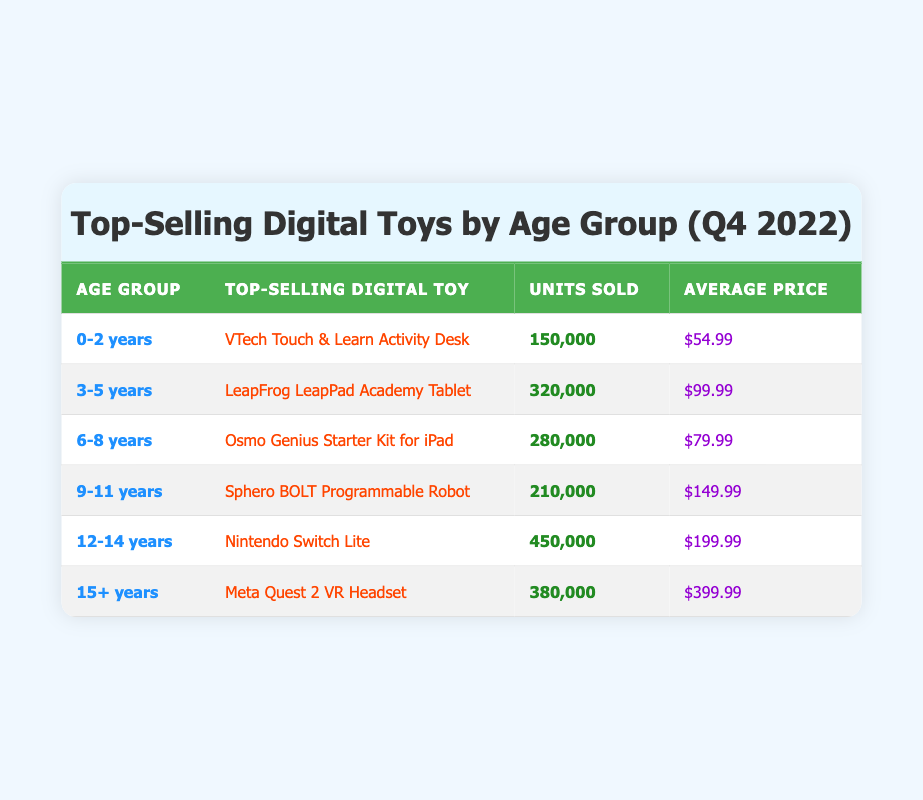What is the top-selling digital toy for the age group 3-5 years? By looking at the age group column for 3-5 years, the top-selling digital toy listed is the LeapFrog LeapPad Academy Tablet.
Answer: LeapFrog LeapPad Academy Tablet How many units of the Nintendo Switch Lite were sold? In the table, the units sold for the Nintendo Switch Lite in the age group of 12-14 years shows a total of 450,000 units.
Answer: 450,000 Which age group has the highest average price for digital toys? To determine this, we analyze the average prices of the toys: 54.99 (0-2 years), 99.99 (3-5 years), 79.99 (6-8 years), 149.99 (9-11 years), 199.99 (12-14 years), and 399.99 (15+ years). The age group 15+ years has the highest average price at 399.99.
Answer: 15+ years Is the VTech Touch & Learn Activity Desk the top-selling toy for any age group? Yes, the VTech Touch & Learn Activity Desk is listed as the top-selling digital toy for the age group of 0-2 years according to the table.
Answer: Yes What is the total number of units sold for toys in the age group 9-11 years and 12-14 years combined? The units sold for the age group 9-11 years is 210,000 and for 12-14 years is 450,000. Adding these together gives 210,000 + 450,000 = 660,000 units combined for these two age groups.
Answer: 660,000 Which toy sold the least units and what is that number? Referring to the units sold for toys, the VTech Touch & Learn Activity Desk sold 150,000 units, making it the toy with the least sales in the table.
Answer: 150,000 What is the difference in units sold between the top-selling toy for 12-14 years and the top-selling toy for 6-8 years? The top-selling toy for 12-14 years (Nintendo Switch Lite) sold 450,000 units, while the 6-8 years (Osmo Genius Starter Kit) sold 280,000 units. The difference is 450,000 - 280,000 = 170,000 units.
Answer: 170,000 Does the table show more toys targeted for younger children than for older children? Yes, the table has three age groups categorized as younger children (0-2, 3-5, and 6-8 years) compared to two age groups for older children (9-11, 12-14, and 15+ years). Three is greater than two, confirming that there are more toys targeted at younger children.
Answer: Yes 